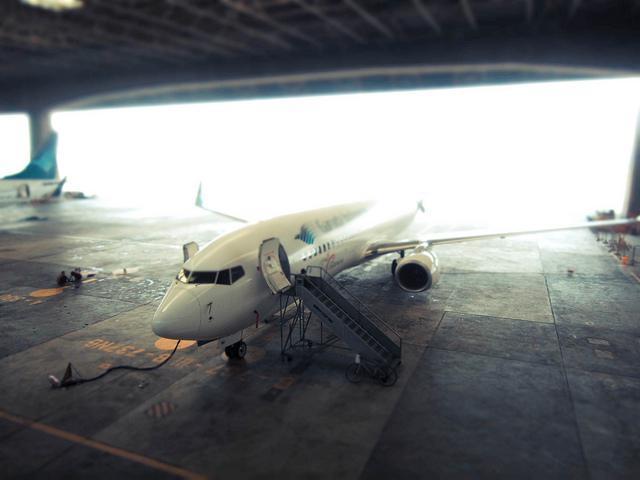How many plane engines are visible?
Give a very brief answer. 1. How many airplanes are in the photo?
Give a very brief answer. 2. 